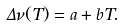Convert formula to latex. <formula><loc_0><loc_0><loc_500><loc_500>\Delta \nu ( T ) = a + b T .</formula> 